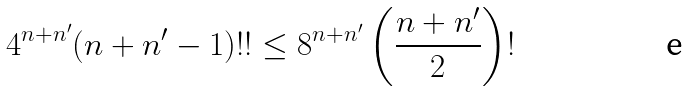Convert formula to latex. <formula><loc_0><loc_0><loc_500><loc_500>4 ^ { n + n ^ { \prime } } ( n + n ^ { \prime } - 1 ) ! ! \leq 8 ^ { n + n ^ { \prime } } \left ( \frac { n + n ^ { \prime } } { 2 } \right ) !</formula> 